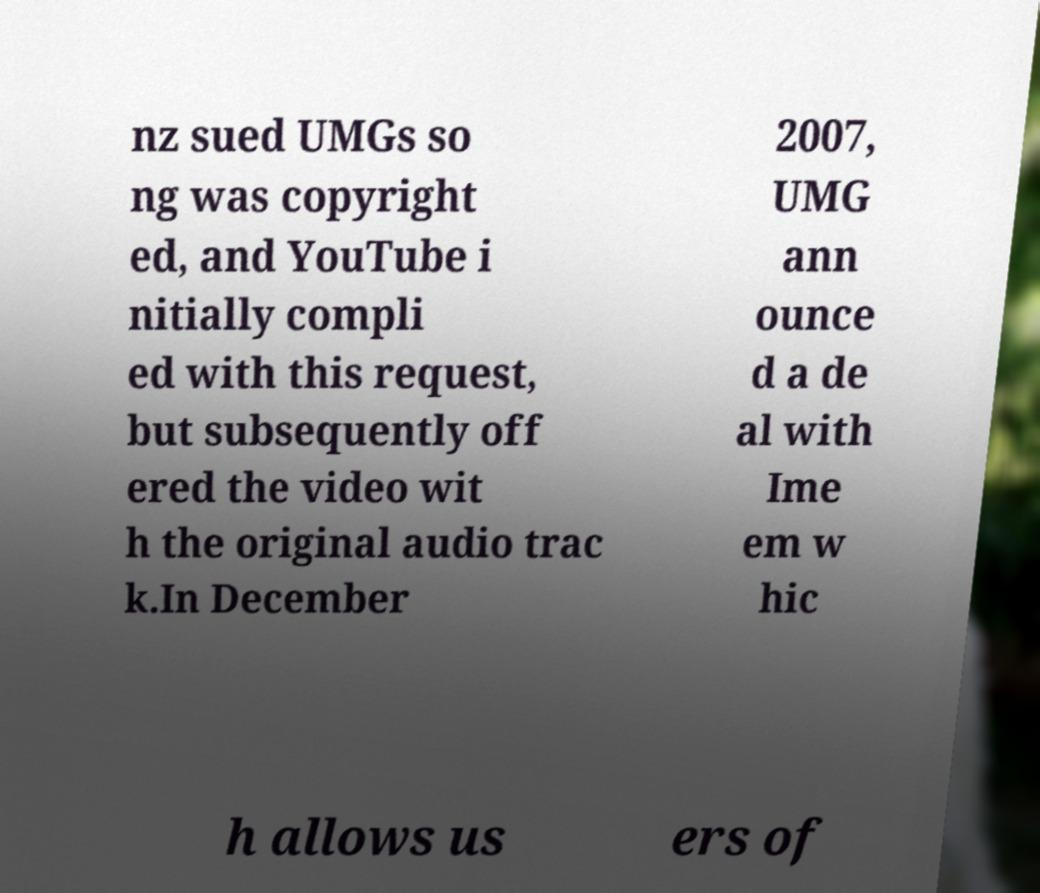For documentation purposes, I need the text within this image transcribed. Could you provide that? nz sued UMGs so ng was copyright ed, and YouTube i nitially compli ed with this request, but subsequently off ered the video wit h the original audio trac k.In December 2007, UMG ann ounce d a de al with Ime em w hic h allows us ers of 